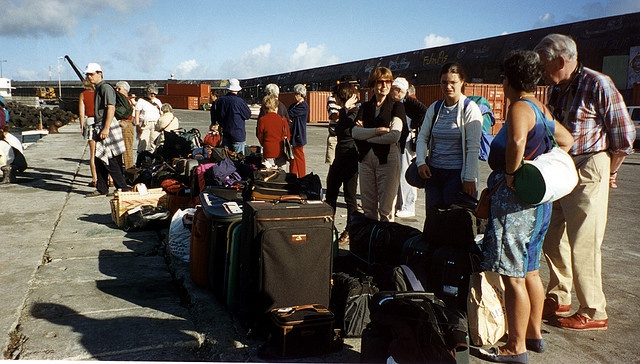Describe the objects in this image and their specific colors. I can see people in darkgray, black, maroon, tan, and beige tones, people in darkgray, black, tan, and maroon tones, suitcase in darkgray, black, and gray tones, people in darkgray, black, gray, and ivory tones, and people in darkgray, black, maroon, and gray tones in this image. 